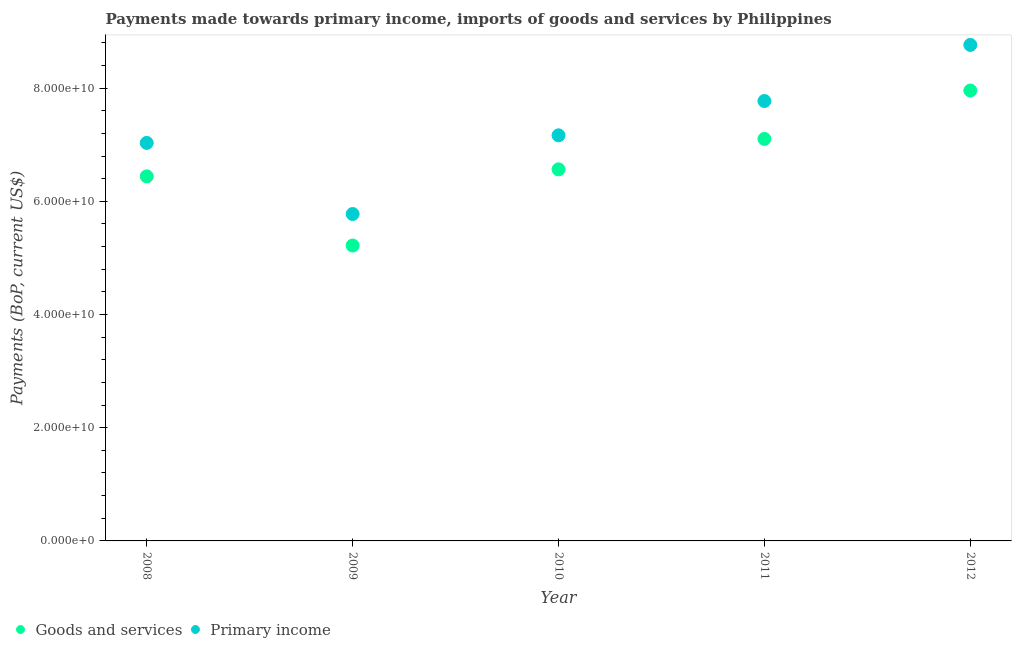What is the payments made towards goods and services in 2008?
Your answer should be very brief. 6.44e+1. Across all years, what is the maximum payments made towards goods and services?
Offer a terse response. 7.96e+1. Across all years, what is the minimum payments made towards goods and services?
Your answer should be very brief. 5.22e+1. In which year was the payments made towards goods and services minimum?
Provide a short and direct response. 2009. What is the total payments made towards goods and services in the graph?
Give a very brief answer. 3.33e+11. What is the difference between the payments made towards goods and services in 2009 and that in 2010?
Offer a very short reply. -1.35e+1. What is the difference between the payments made towards goods and services in 2008 and the payments made towards primary income in 2009?
Your response must be concise. 6.66e+09. What is the average payments made towards primary income per year?
Your answer should be compact. 7.30e+1. In the year 2009, what is the difference between the payments made towards goods and services and payments made towards primary income?
Your answer should be compact. -5.56e+09. What is the ratio of the payments made towards primary income in 2011 to that in 2012?
Provide a succinct answer. 0.89. Is the payments made towards primary income in 2010 less than that in 2011?
Offer a terse response. Yes. What is the difference between the highest and the second highest payments made towards goods and services?
Offer a terse response. 8.55e+09. What is the difference between the highest and the lowest payments made towards goods and services?
Offer a terse response. 2.74e+1. Is the sum of the payments made towards goods and services in 2008 and 2012 greater than the maximum payments made towards primary income across all years?
Offer a terse response. Yes. Does the payments made towards primary income monotonically increase over the years?
Offer a terse response. No. Are the values on the major ticks of Y-axis written in scientific E-notation?
Give a very brief answer. Yes. Does the graph contain any zero values?
Provide a short and direct response. No. Does the graph contain grids?
Keep it short and to the point. No. Where does the legend appear in the graph?
Your answer should be very brief. Bottom left. What is the title of the graph?
Your answer should be compact. Payments made towards primary income, imports of goods and services by Philippines. Does "Technicians" appear as one of the legend labels in the graph?
Make the answer very short. No. What is the label or title of the Y-axis?
Your response must be concise. Payments (BoP, current US$). What is the Payments (BoP, current US$) of Goods and services in 2008?
Provide a short and direct response. 6.44e+1. What is the Payments (BoP, current US$) in Primary income in 2008?
Give a very brief answer. 7.03e+1. What is the Payments (BoP, current US$) in Goods and services in 2009?
Offer a very short reply. 5.22e+1. What is the Payments (BoP, current US$) in Primary income in 2009?
Offer a very short reply. 5.78e+1. What is the Payments (BoP, current US$) of Goods and services in 2010?
Keep it short and to the point. 6.56e+1. What is the Payments (BoP, current US$) of Primary income in 2010?
Make the answer very short. 7.17e+1. What is the Payments (BoP, current US$) in Goods and services in 2011?
Your answer should be compact. 7.10e+1. What is the Payments (BoP, current US$) of Primary income in 2011?
Provide a succinct answer. 7.77e+1. What is the Payments (BoP, current US$) in Goods and services in 2012?
Keep it short and to the point. 7.96e+1. What is the Payments (BoP, current US$) of Primary income in 2012?
Offer a very short reply. 8.76e+1. Across all years, what is the maximum Payments (BoP, current US$) of Goods and services?
Offer a very short reply. 7.96e+1. Across all years, what is the maximum Payments (BoP, current US$) in Primary income?
Your response must be concise. 8.76e+1. Across all years, what is the minimum Payments (BoP, current US$) of Goods and services?
Keep it short and to the point. 5.22e+1. Across all years, what is the minimum Payments (BoP, current US$) in Primary income?
Keep it short and to the point. 5.78e+1. What is the total Payments (BoP, current US$) of Goods and services in the graph?
Make the answer very short. 3.33e+11. What is the total Payments (BoP, current US$) of Primary income in the graph?
Keep it short and to the point. 3.65e+11. What is the difference between the Payments (BoP, current US$) in Goods and services in 2008 and that in 2009?
Your response must be concise. 1.22e+1. What is the difference between the Payments (BoP, current US$) of Primary income in 2008 and that in 2009?
Provide a succinct answer. 1.26e+1. What is the difference between the Payments (BoP, current US$) of Goods and services in 2008 and that in 2010?
Offer a very short reply. -1.24e+09. What is the difference between the Payments (BoP, current US$) of Primary income in 2008 and that in 2010?
Offer a terse response. -1.35e+09. What is the difference between the Payments (BoP, current US$) of Goods and services in 2008 and that in 2011?
Your answer should be compact. -6.61e+09. What is the difference between the Payments (BoP, current US$) of Primary income in 2008 and that in 2011?
Your answer should be compact. -7.40e+09. What is the difference between the Payments (BoP, current US$) of Goods and services in 2008 and that in 2012?
Give a very brief answer. -1.52e+1. What is the difference between the Payments (BoP, current US$) of Primary income in 2008 and that in 2012?
Offer a very short reply. -1.73e+1. What is the difference between the Payments (BoP, current US$) of Goods and services in 2009 and that in 2010?
Your answer should be compact. -1.35e+1. What is the difference between the Payments (BoP, current US$) in Primary income in 2009 and that in 2010?
Offer a terse response. -1.39e+1. What is the difference between the Payments (BoP, current US$) in Goods and services in 2009 and that in 2011?
Offer a terse response. -1.88e+1. What is the difference between the Payments (BoP, current US$) of Primary income in 2009 and that in 2011?
Keep it short and to the point. -2.00e+1. What is the difference between the Payments (BoP, current US$) in Goods and services in 2009 and that in 2012?
Make the answer very short. -2.74e+1. What is the difference between the Payments (BoP, current US$) of Primary income in 2009 and that in 2012?
Ensure brevity in your answer.  -2.99e+1. What is the difference between the Payments (BoP, current US$) in Goods and services in 2010 and that in 2011?
Your answer should be very brief. -5.37e+09. What is the difference between the Payments (BoP, current US$) in Primary income in 2010 and that in 2011?
Offer a terse response. -6.06e+09. What is the difference between the Payments (BoP, current US$) in Goods and services in 2010 and that in 2012?
Offer a very short reply. -1.39e+1. What is the difference between the Payments (BoP, current US$) of Primary income in 2010 and that in 2012?
Your response must be concise. -1.60e+1. What is the difference between the Payments (BoP, current US$) in Goods and services in 2011 and that in 2012?
Offer a terse response. -8.55e+09. What is the difference between the Payments (BoP, current US$) of Primary income in 2011 and that in 2012?
Your answer should be very brief. -9.91e+09. What is the difference between the Payments (BoP, current US$) in Goods and services in 2008 and the Payments (BoP, current US$) in Primary income in 2009?
Ensure brevity in your answer.  6.66e+09. What is the difference between the Payments (BoP, current US$) in Goods and services in 2008 and the Payments (BoP, current US$) in Primary income in 2010?
Ensure brevity in your answer.  -7.25e+09. What is the difference between the Payments (BoP, current US$) of Goods and services in 2008 and the Payments (BoP, current US$) of Primary income in 2011?
Provide a short and direct response. -1.33e+1. What is the difference between the Payments (BoP, current US$) of Goods and services in 2008 and the Payments (BoP, current US$) of Primary income in 2012?
Provide a succinct answer. -2.32e+1. What is the difference between the Payments (BoP, current US$) in Goods and services in 2009 and the Payments (BoP, current US$) in Primary income in 2010?
Your response must be concise. -1.95e+1. What is the difference between the Payments (BoP, current US$) of Goods and services in 2009 and the Payments (BoP, current US$) of Primary income in 2011?
Offer a very short reply. -2.55e+1. What is the difference between the Payments (BoP, current US$) in Goods and services in 2009 and the Payments (BoP, current US$) in Primary income in 2012?
Provide a short and direct response. -3.54e+1. What is the difference between the Payments (BoP, current US$) in Goods and services in 2010 and the Payments (BoP, current US$) in Primary income in 2011?
Ensure brevity in your answer.  -1.21e+1. What is the difference between the Payments (BoP, current US$) of Goods and services in 2010 and the Payments (BoP, current US$) of Primary income in 2012?
Your answer should be very brief. -2.20e+1. What is the difference between the Payments (BoP, current US$) of Goods and services in 2011 and the Payments (BoP, current US$) of Primary income in 2012?
Provide a succinct answer. -1.66e+1. What is the average Payments (BoP, current US$) of Goods and services per year?
Your response must be concise. 6.66e+1. What is the average Payments (BoP, current US$) of Primary income per year?
Offer a very short reply. 7.30e+1. In the year 2008, what is the difference between the Payments (BoP, current US$) in Goods and services and Payments (BoP, current US$) in Primary income?
Your response must be concise. -5.90e+09. In the year 2009, what is the difference between the Payments (BoP, current US$) of Goods and services and Payments (BoP, current US$) of Primary income?
Make the answer very short. -5.56e+09. In the year 2010, what is the difference between the Payments (BoP, current US$) in Goods and services and Payments (BoP, current US$) in Primary income?
Your answer should be compact. -6.01e+09. In the year 2011, what is the difference between the Payments (BoP, current US$) in Goods and services and Payments (BoP, current US$) in Primary income?
Provide a succinct answer. -6.70e+09. In the year 2012, what is the difference between the Payments (BoP, current US$) in Goods and services and Payments (BoP, current US$) in Primary income?
Make the answer very short. -8.06e+09. What is the ratio of the Payments (BoP, current US$) in Goods and services in 2008 to that in 2009?
Give a very brief answer. 1.23. What is the ratio of the Payments (BoP, current US$) in Primary income in 2008 to that in 2009?
Offer a very short reply. 1.22. What is the ratio of the Payments (BoP, current US$) in Goods and services in 2008 to that in 2010?
Offer a terse response. 0.98. What is the ratio of the Payments (BoP, current US$) in Primary income in 2008 to that in 2010?
Make the answer very short. 0.98. What is the ratio of the Payments (BoP, current US$) of Goods and services in 2008 to that in 2011?
Offer a very short reply. 0.91. What is the ratio of the Payments (BoP, current US$) of Primary income in 2008 to that in 2011?
Ensure brevity in your answer.  0.9. What is the ratio of the Payments (BoP, current US$) in Goods and services in 2008 to that in 2012?
Provide a succinct answer. 0.81. What is the ratio of the Payments (BoP, current US$) in Primary income in 2008 to that in 2012?
Offer a terse response. 0.8. What is the ratio of the Payments (BoP, current US$) of Goods and services in 2009 to that in 2010?
Your answer should be compact. 0.8. What is the ratio of the Payments (BoP, current US$) of Primary income in 2009 to that in 2010?
Make the answer very short. 0.81. What is the ratio of the Payments (BoP, current US$) in Goods and services in 2009 to that in 2011?
Offer a terse response. 0.73. What is the ratio of the Payments (BoP, current US$) of Primary income in 2009 to that in 2011?
Keep it short and to the point. 0.74. What is the ratio of the Payments (BoP, current US$) in Goods and services in 2009 to that in 2012?
Provide a short and direct response. 0.66. What is the ratio of the Payments (BoP, current US$) of Primary income in 2009 to that in 2012?
Your response must be concise. 0.66. What is the ratio of the Payments (BoP, current US$) in Goods and services in 2010 to that in 2011?
Provide a short and direct response. 0.92. What is the ratio of the Payments (BoP, current US$) of Primary income in 2010 to that in 2011?
Your answer should be very brief. 0.92. What is the ratio of the Payments (BoP, current US$) in Goods and services in 2010 to that in 2012?
Make the answer very short. 0.82. What is the ratio of the Payments (BoP, current US$) in Primary income in 2010 to that in 2012?
Offer a very short reply. 0.82. What is the ratio of the Payments (BoP, current US$) of Goods and services in 2011 to that in 2012?
Your answer should be compact. 0.89. What is the ratio of the Payments (BoP, current US$) in Primary income in 2011 to that in 2012?
Your answer should be very brief. 0.89. What is the difference between the highest and the second highest Payments (BoP, current US$) in Goods and services?
Provide a short and direct response. 8.55e+09. What is the difference between the highest and the second highest Payments (BoP, current US$) in Primary income?
Provide a succinct answer. 9.91e+09. What is the difference between the highest and the lowest Payments (BoP, current US$) of Goods and services?
Offer a very short reply. 2.74e+1. What is the difference between the highest and the lowest Payments (BoP, current US$) in Primary income?
Provide a short and direct response. 2.99e+1. 